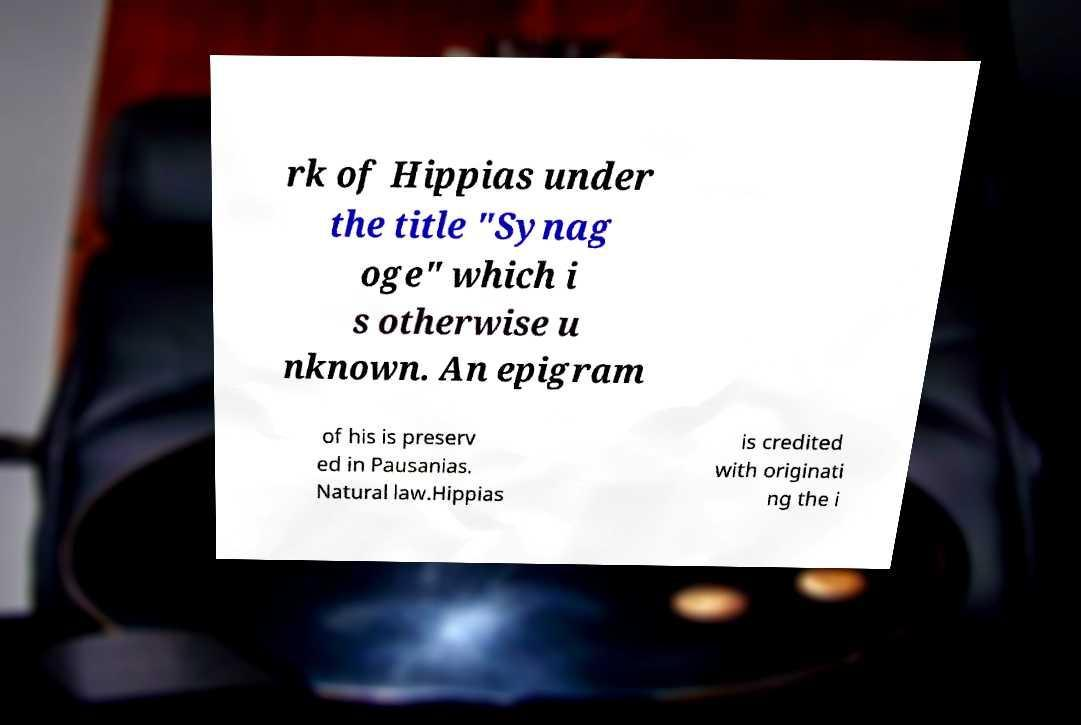Please read and relay the text visible in this image. What does it say? rk of Hippias under the title "Synag oge" which i s otherwise u nknown. An epigram of his is preserv ed in Pausanias. Natural law.Hippias is credited with originati ng the i 